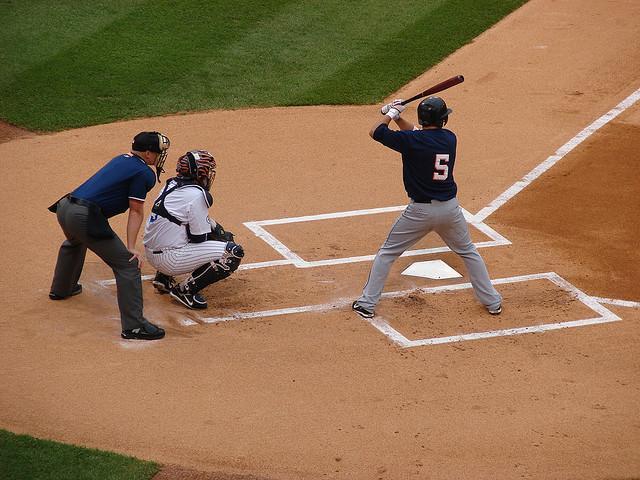How many people are there?
Give a very brief answer. 3. How many layers does this cake have?
Give a very brief answer. 0. 